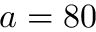Convert formula to latex. <formula><loc_0><loc_0><loc_500><loc_500>a = 8 0</formula> 